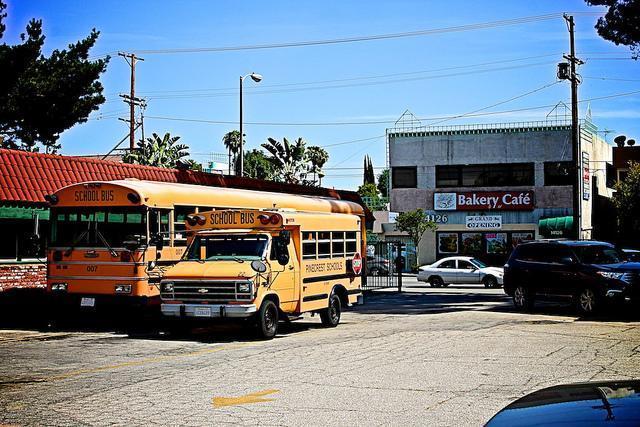How many cars are there?
Give a very brief answer. 3. How many buses are there?
Give a very brief answer. 2. 